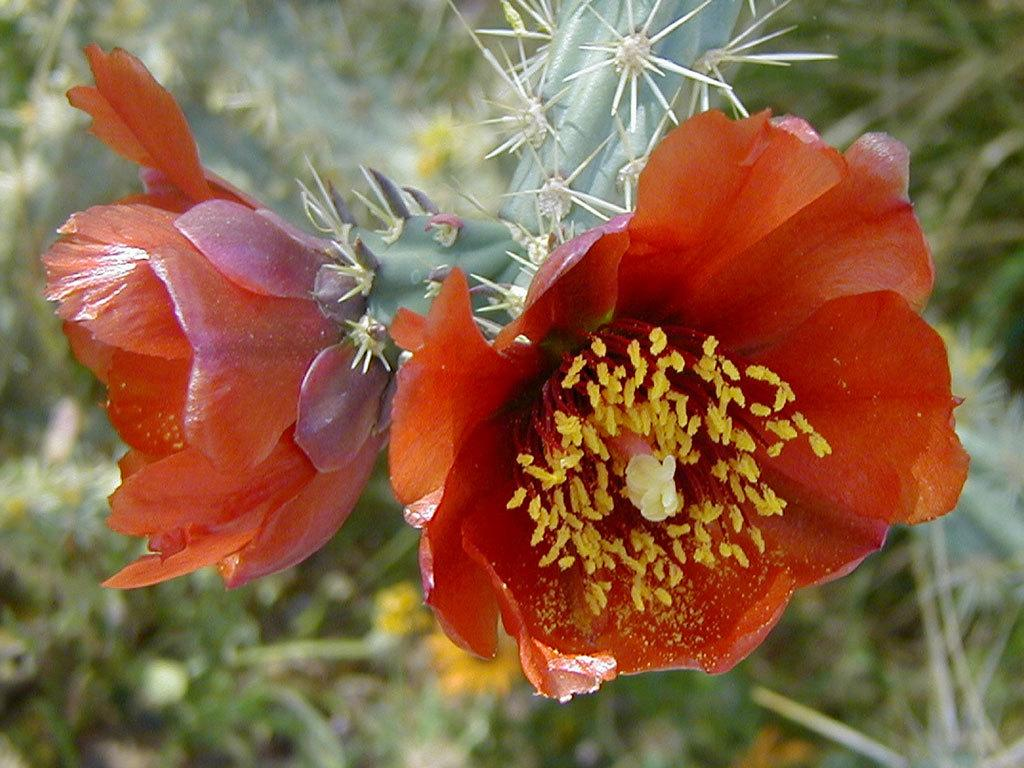What type of living organisms can be seen in the image? There are flowers on a plant in the image. Can you describe the background of the image? There are plants visible in the background of the image. What direction is the car facing in the image? There is no car present in the image. 